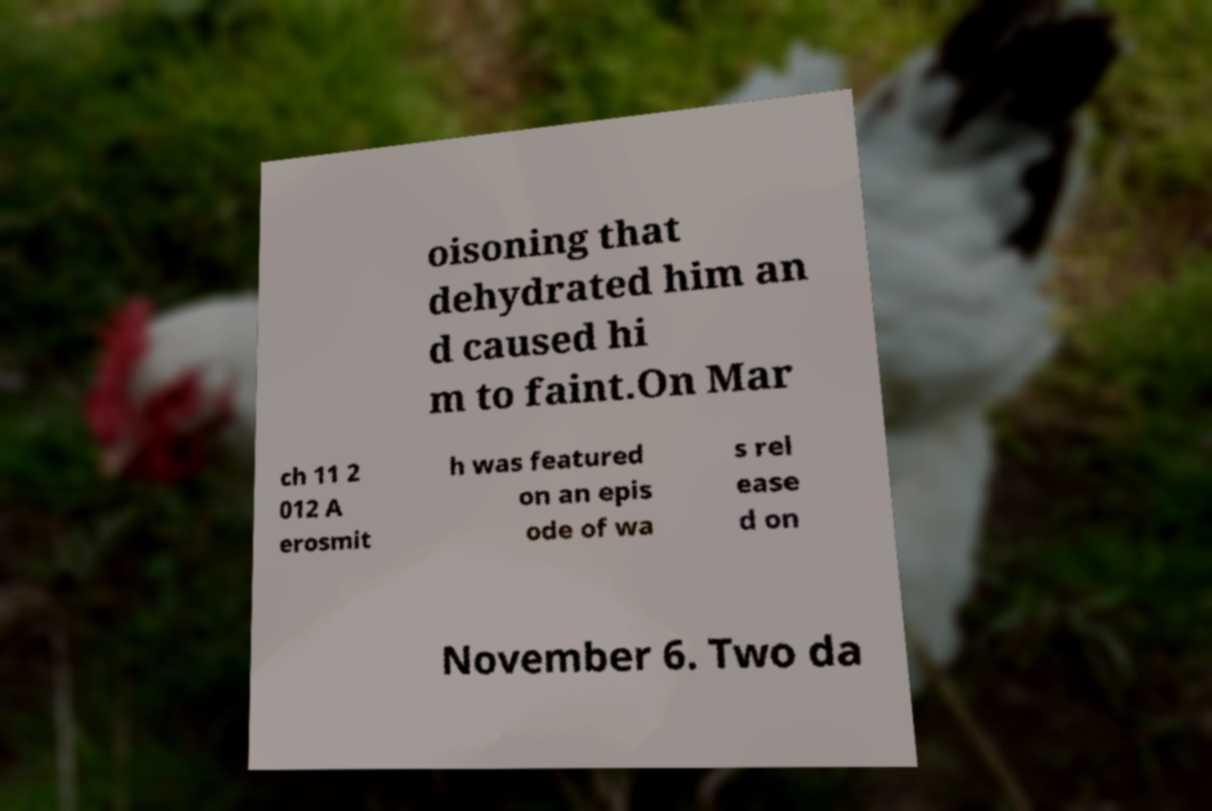What messages or text are displayed in this image? I need them in a readable, typed format. oisoning that dehydrated him an d caused hi m to faint.On Mar ch 11 2 012 A erosmit h was featured on an epis ode of wa s rel ease d on November 6. Two da 